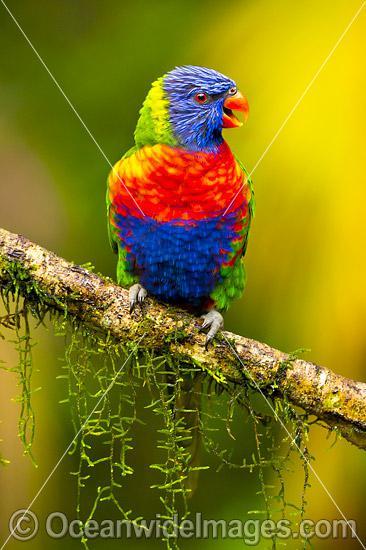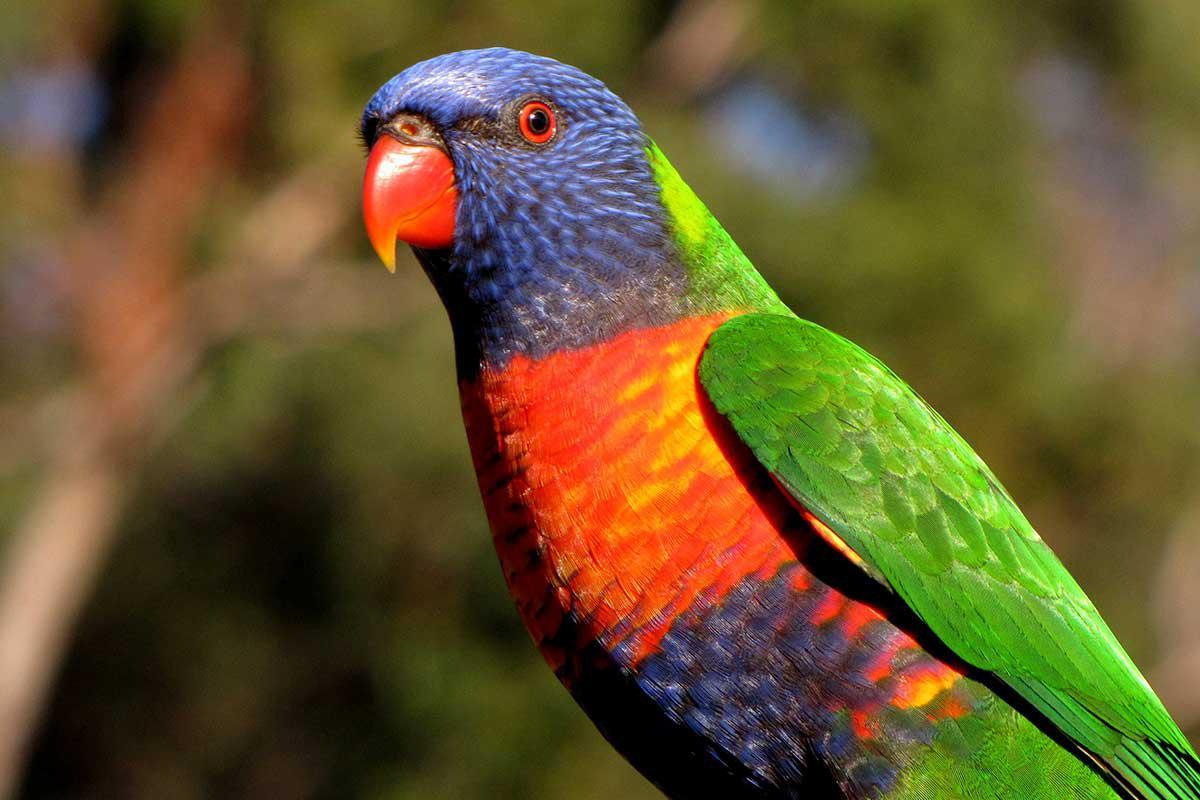The first image is the image on the left, the second image is the image on the right. For the images shown, is this caption "There is no more than two parrots." true? Answer yes or no. Yes. 